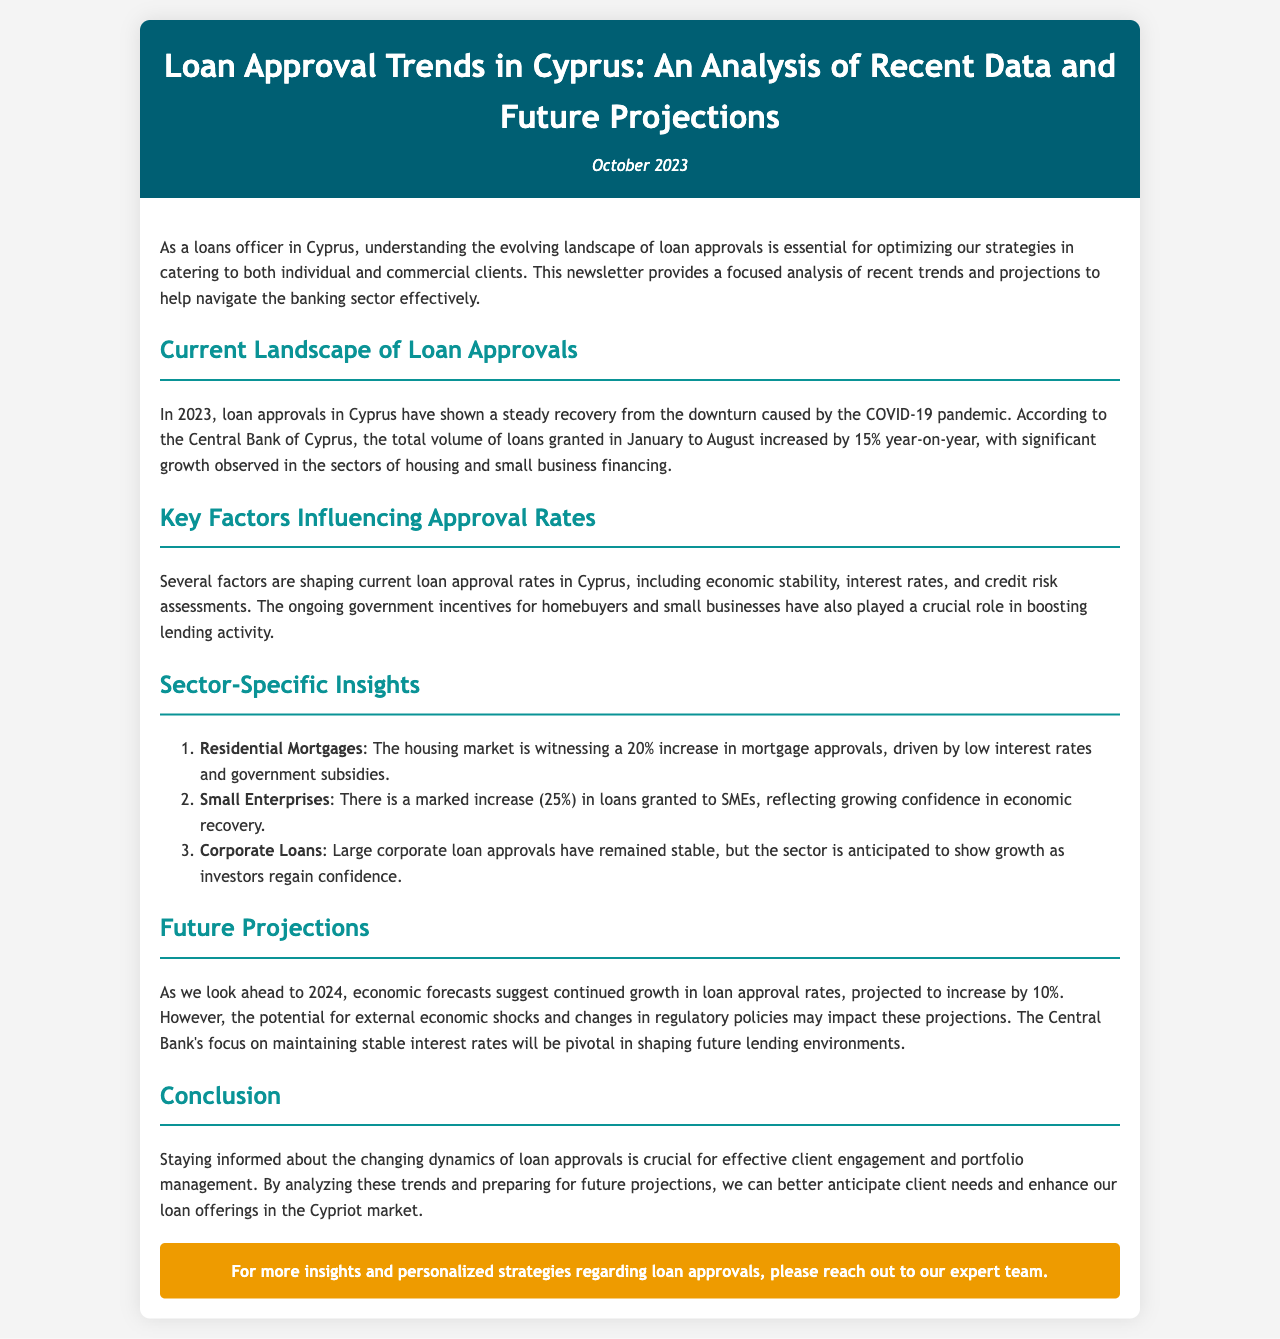What is the percentage increase in loan approvals from January to August 2023? The document states that loan approvals in Cyprus increased by 15% year-on-year during this period.
Answer: 15% What factors are influencing loan approval rates? Several factors such as economic stability, interest rates, and credit risk assessments are influencing the rate, as mentioned in the document.
Answer: Economic stability, interest rates, credit risk assessments What is the projected increase in loan approval rates for 2024? The document forecasts a 10% increase in loan approval rates for the year 2024.
Answer: 10% Which sector saw a 25% increase in loans granted? The newsletter specifically mentions that loans granted to small enterprises increased by 25%.
Answer: Small Enterprises What is the significant growth observed in residential mortgages? A 20% increase in mortgage approvals is highlighted in the document, due to low interest rates and government subsidies.
Answer: 20% What role do government incentives play in loan approvals? The document indicates that government incentives for homebuyers and small businesses have been crucial in boosting lending activity.
Answer: Crucial What is the date of the newsletter publication? The newsletter is dated October 2023, as indicated in the header section.
Answer: October 2023 What does the conclusion emphasize regarding client engagement? The conclusion emphasizes staying informed about changing dynamics for effective client engagement and portfolio management.
Answer: Effective client engagement What has been the trend for corporate loan approvals? The document mentions that large corporate loan approvals have remained stable.
Answer: Stable 